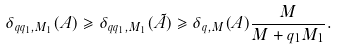Convert formula to latex. <formula><loc_0><loc_0><loc_500><loc_500>\delta _ { q q _ { 1 } , M _ { 1 } } ( A ) \geqslant \delta _ { q q _ { 1 } , M _ { 1 } } ( \tilde { A } ) \geqslant \delta _ { q , M } ( A ) \frac { M } { M + q _ { 1 } M _ { 1 } } .</formula> 